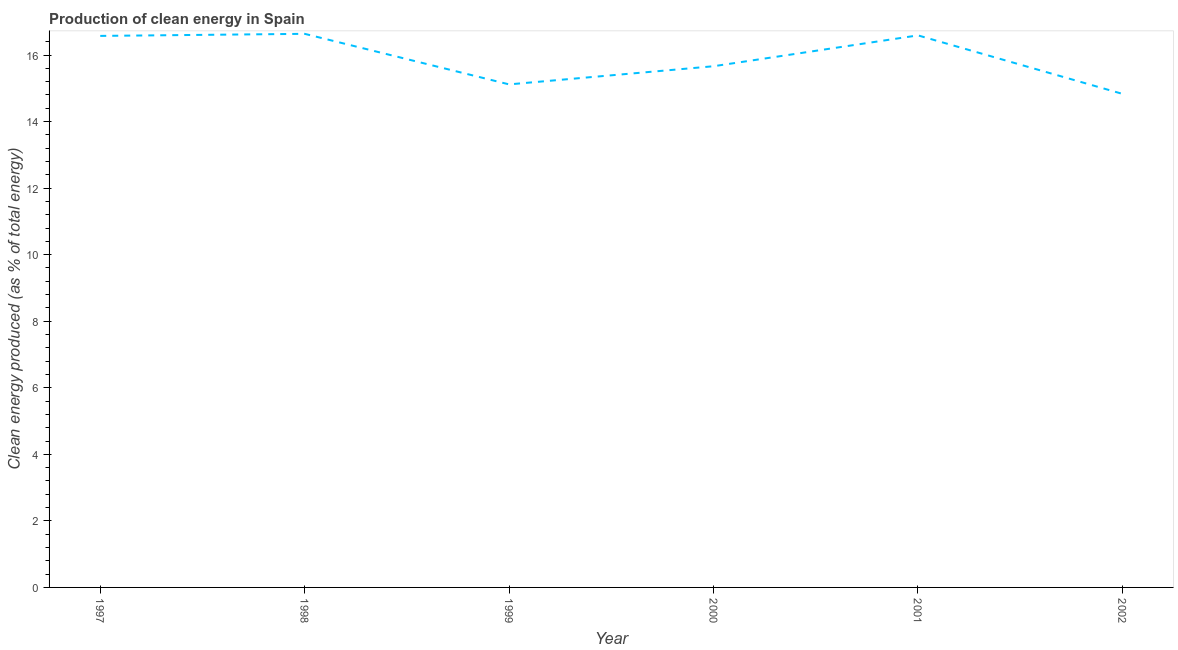What is the production of clean energy in 1999?
Offer a very short reply. 15.12. Across all years, what is the maximum production of clean energy?
Offer a very short reply. 16.64. Across all years, what is the minimum production of clean energy?
Your answer should be compact. 14.83. In which year was the production of clean energy maximum?
Your response must be concise. 1998. In which year was the production of clean energy minimum?
Offer a terse response. 2002. What is the sum of the production of clean energy?
Offer a very short reply. 95.41. What is the difference between the production of clean energy in 1999 and 2002?
Your answer should be compact. 0.28. What is the average production of clean energy per year?
Make the answer very short. 15.9. What is the median production of clean energy?
Provide a succinct answer. 16.12. In how many years, is the production of clean energy greater than 6 %?
Ensure brevity in your answer.  6. What is the ratio of the production of clean energy in 1997 to that in 2001?
Ensure brevity in your answer.  1. Is the production of clean energy in 1997 less than that in 1998?
Provide a short and direct response. Yes. Is the difference between the production of clean energy in 2001 and 2002 greater than the difference between any two years?
Ensure brevity in your answer.  No. What is the difference between the highest and the second highest production of clean energy?
Give a very brief answer. 0.05. What is the difference between the highest and the lowest production of clean energy?
Ensure brevity in your answer.  1.8. Does the production of clean energy monotonically increase over the years?
Make the answer very short. No. How many lines are there?
Ensure brevity in your answer.  1. How many years are there in the graph?
Give a very brief answer. 6. What is the difference between two consecutive major ticks on the Y-axis?
Your answer should be very brief. 2. Does the graph contain grids?
Provide a short and direct response. No. What is the title of the graph?
Offer a very short reply. Production of clean energy in Spain. What is the label or title of the X-axis?
Make the answer very short. Year. What is the label or title of the Y-axis?
Keep it short and to the point. Clean energy produced (as % of total energy). What is the Clean energy produced (as % of total energy) in 1997?
Offer a very short reply. 16.57. What is the Clean energy produced (as % of total energy) of 1998?
Offer a very short reply. 16.64. What is the Clean energy produced (as % of total energy) of 1999?
Ensure brevity in your answer.  15.12. What is the Clean energy produced (as % of total energy) in 2000?
Offer a very short reply. 15.66. What is the Clean energy produced (as % of total energy) in 2001?
Offer a very short reply. 16.59. What is the Clean energy produced (as % of total energy) of 2002?
Your answer should be very brief. 14.83. What is the difference between the Clean energy produced (as % of total energy) in 1997 and 1998?
Ensure brevity in your answer.  -0.06. What is the difference between the Clean energy produced (as % of total energy) in 1997 and 1999?
Your answer should be compact. 1.46. What is the difference between the Clean energy produced (as % of total energy) in 1997 and 2000?
Ensure brevity in your answer.  0.91. What is the difference between the Clean energy produced (as % of total energy) in 1997 and 2001?
Offer a terse response. -0.02. What is the difference between the Clean energy produced (as % of total energy) in 1997 and 2002?
Give a very brief answer. 1.74. What is the difference between the Clean energy produced (as % of total energy) in 1998 and 1999?
Your answer should be very brief. 1.52. What is the difference between the Clean energy produced (as % of total energy) in 1998 and 2000?
Offer a very short reply. 0.97. What is the difference between the Clean energy produced (as % of total energy) in 1998 and 2001?
Make the answer very short. 0.05. What is the difference between the Clean energy produced (as % of total energy) in 1998 and 2002?
Ensure brevity in your answer.  1.8. What is the difference between the Clean energy produced (as % of total energy) in 1999 and 2000?
Provide a succinct answer. -0.55. What is the difference between the Clean energy produced (as % of total energy) in 1999 and 2001?
Your response must be concise. -1.47. What is the difference between the Clean energy produced (as % of total energy) in 1999 and 2002?
Your answer should be compact. 0.28. What is the difference between the Clean energy produced (as % of total energy) in 2000 and 2001?
Provide a short and direct response. -0.93. What is the difference between the Clean energy produced (as % of total energy) in 2000 and 2002?
Keep it short and to the point. 0.83. What is the difference between the Clean energy produced (as % of total energy) in 2001 and 2002?
Offer a terse response. 1.76. What is the ratio of the Clean energy produced (as % of total energy) in 1997 to that in 1998?
Ensure brevity in your answer.  1. What is the ratio of the Clean energy produced (as % of total energy) in 1997 to that in 1999?
Give a very brief answer. 1.1. What is the ratio of the Clean energy produced (as % of total energy) in 1997 to that in 2000?
Offer a terse response. 1.06. What is the ratio of the Clean energy produced (as % of total energy) in 1997 to that in 2001?
Provide a succinct answer. 1. What is the ratio of the Clean energy produced (as % of total energy) in 1997 to that in 2002?
Provide a short and direct response. 1.12. What is the ratio of the Clean energy produced (as % of total energy) in 1998 to that in 1999?
Provide a short and direct response. 1.1. What is the ratio of the Clean energy produced (as % of total energy) in 1998 to that in 2000?
Provide a succinct answer. 1.06. What is the ratio of the Clean energy produced (as % of total energy) in 1998 to that in 2002?
Provide a short and direct response. 1.12. What is the ratio of the Clean energy produced (as % of total energy) in 1999 to that in 2000?
Your response must be concise. 0.96. What is the ratio of the Clean energy produced (as % of total energy) in 1999 to that in 2001?
Offer a terse response. 0.91. What is the ratio of the Clean energy produced (as % of total energy) in 2000 to that in 2001?
Make the answer very short. 0.94. What is the ratio of the Clean energy produced (as % of total energy) in 2000 to that in 2002?
Ensure brevity in your answer.  1.06. What is the ratio of the Clean energy produced (as % of total energy) in 2001 to that in 2002?
Your response must be concise. 1.12. 